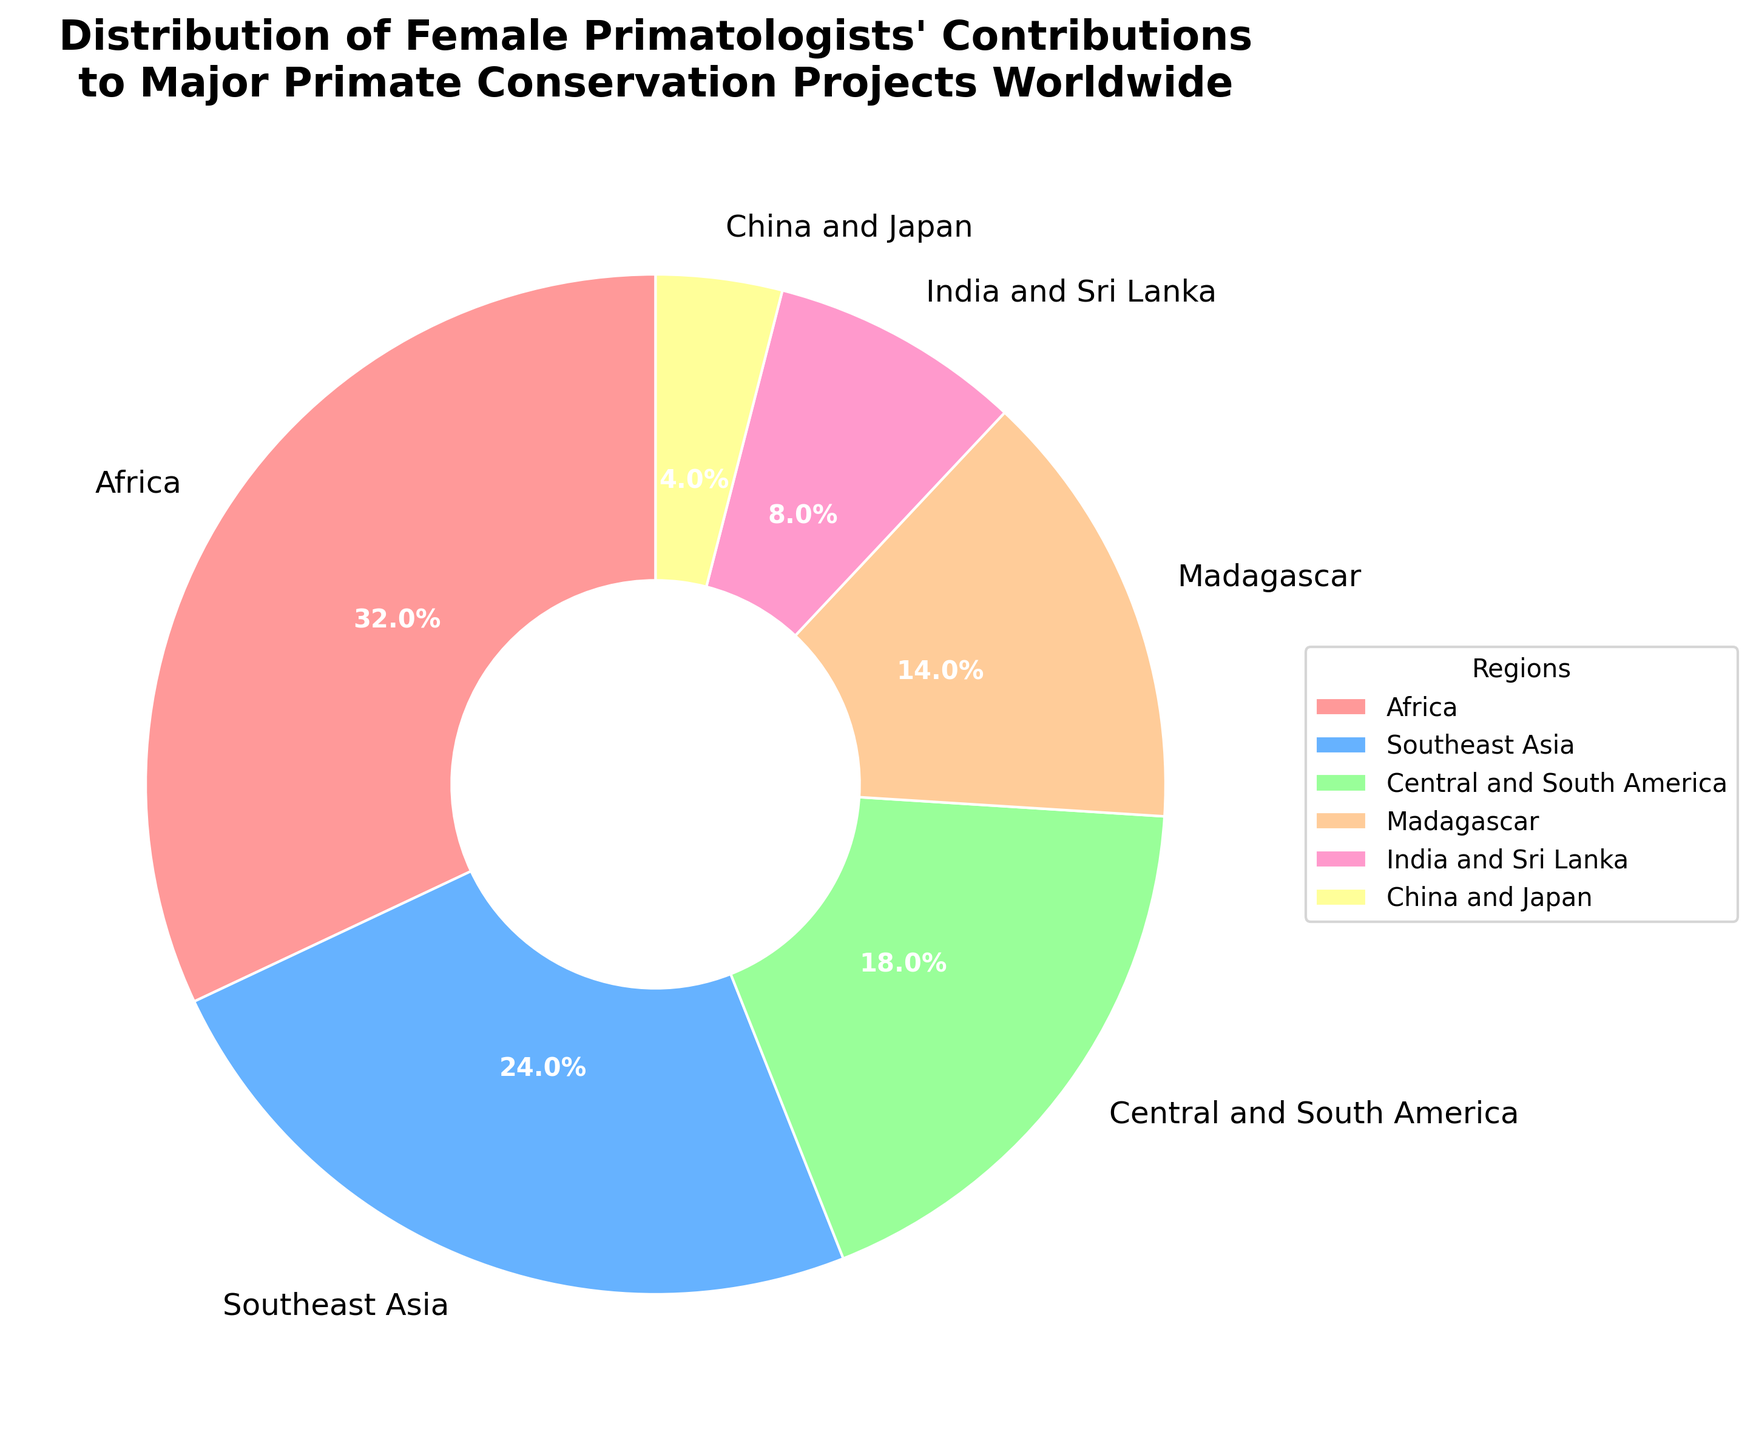Which region has the highest contribution from female primatologists? The figure shows a pie chart with various regions and their respective percentages. The region with the highest percentage (32%) is Africa
Answer: Africa What is the combined contribution percentage of female primatologists in Africa and Southeast Asia? The pie chart indicates the percentages for Africa (32%) and Southeast Asia (24%). Adding these percentages together: 32% + 24% = 56%
Answer: 56% Which region's female primatologists contribute the least to major primate conservation projects? By looking at the pie chart, China and Japan have the smallest wedge at 4%
Answer: China and Japan Are the contributions from female primatologists in Central and South America greater than those in Madagascar? According to the pie chart, Central and South America accounts for 18% while Madagascar accounts for 14%. Since 18% is greater than 14%, the contributions from Central and South America are greater
Answer: Yes What is the percentage difference between the contributions of female primatologists in India and Sri Lanka compared to China and Japan? India and Sri Lanka have a 8% contribution while China and Japan have a 4% contribution. The difference between these two percentages is 8% - 4% = 4%
Answer: 4% If the contributions from female primatologists in Southeast Asia were to increase by 6%, how would that change the overall distribution? Currently, Southeast Asia contributes 24%. If it increased by 6%, it would be 24% + 6% = 30%. The new distribution would be recalculated based on the updated percentages where Southeast Asia's contribution is now 30%
Answer: Southeast Asia: 30% Which region is represented by the light green color in the pie chart? The pie chart uses a specific color palette, and the region represented by the light green color is Central and South America, which corresponds to 18%
Answer: Central and South America What is the combined contribution of female primatologists from India and Sri Lanka, and China and Japan? The pie chart shows the contributions as 8% for India and Sri Lanka and 4% for China and Japan. Adding these percentages together: 8% + 4% = 12%
Answer: 12% 